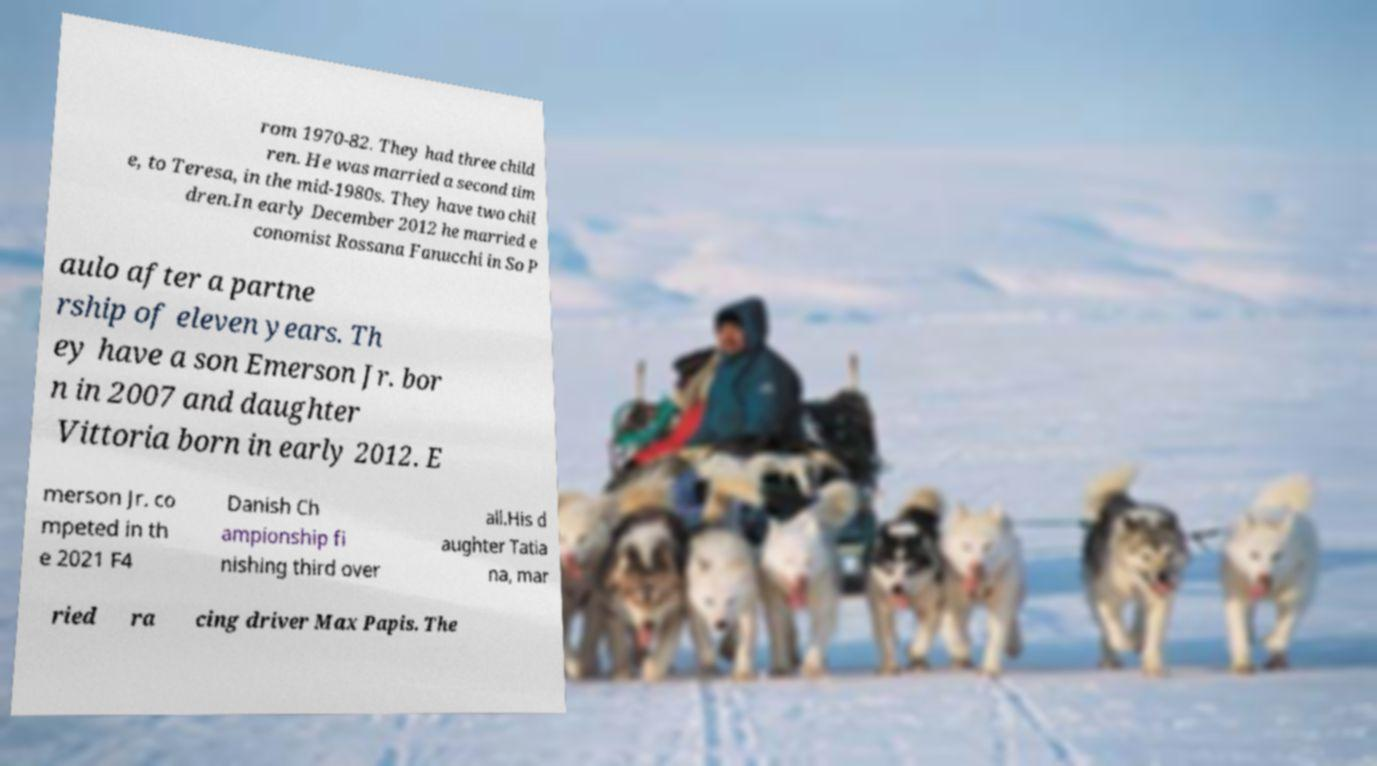For documentation purposes, I need the text within this image transcribed. Could you provide that? rom 1970-82. They had three child ren. He was married a second tim e, to Teresa, in the mid-1980s. They have two chil dren.In early December 2012 he married e conomist Rossana Fanucchi in So P aulo after a partne rship of eleven years. Th ey have a son Emerson Jr. bor n in 2007 and daughter Vittoria born in early 2012. E merson Jr. co mpeted in th e 2021 F4 Danish Ch ampionship fi nishing third over all.His d aughter Tatia na, mar ried ra cing driver Max Papis. The 